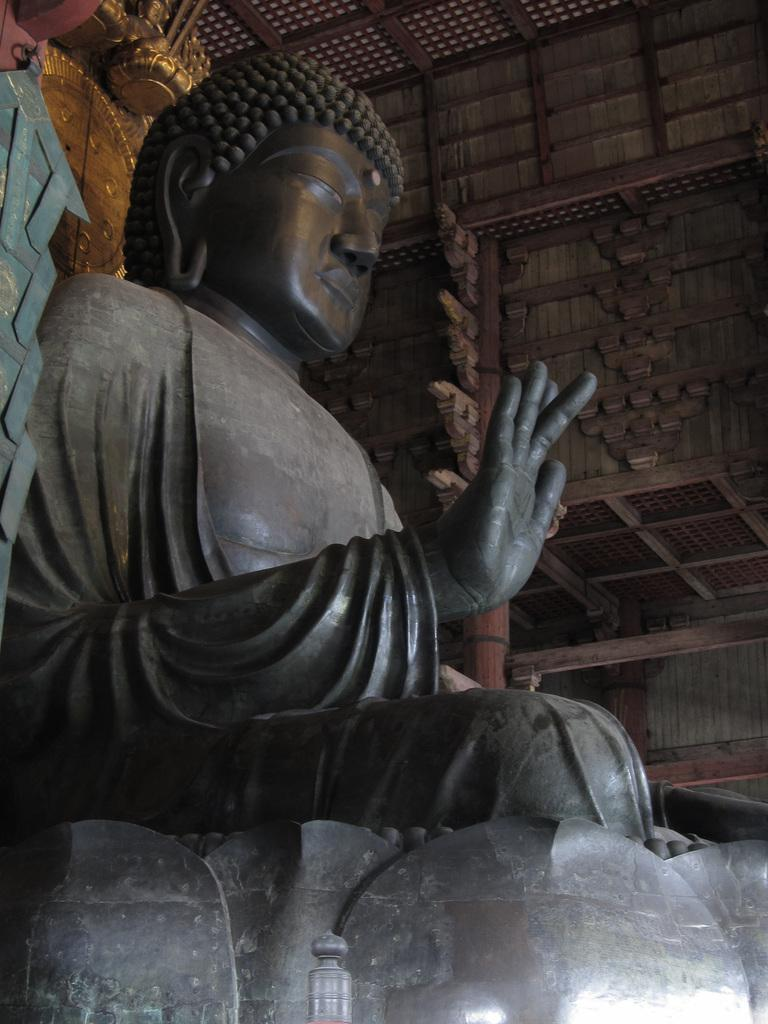Where was the image likely taken? The image appears to be taken inside a building. What can be seen in the image besides the building's interior? There is a sculpture and a wooden stick with a design in the image. What type of car is visible through the window in the image? There is no car or window present in the image; it only features a sculpture and a wooden stick with a design. 